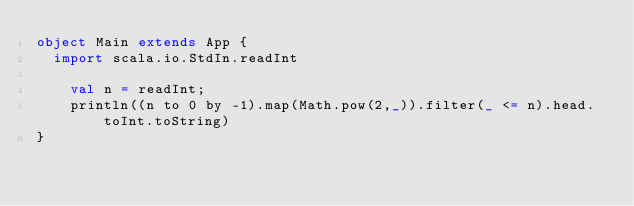<code> <loc_0><loc_0><loc_500><loc_500><_Scala_>object Main extends App {
  import scala.io.StdIn.readInt
  
  	val n = readInt;
  	println((n to 0 by -1).map(Math.pow(2,_)).filter(_ <= n).head.toInt.toString)   
}
</code> 